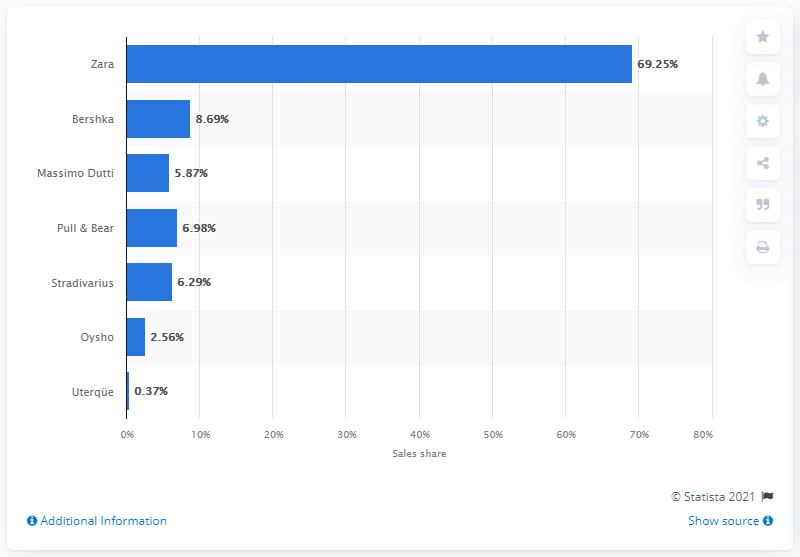Give some essential details in this illustration. According to the Inditex Group's sales figures for 2020, Zara was the company that captured the largest share of total sales, approximately 69 percent. 